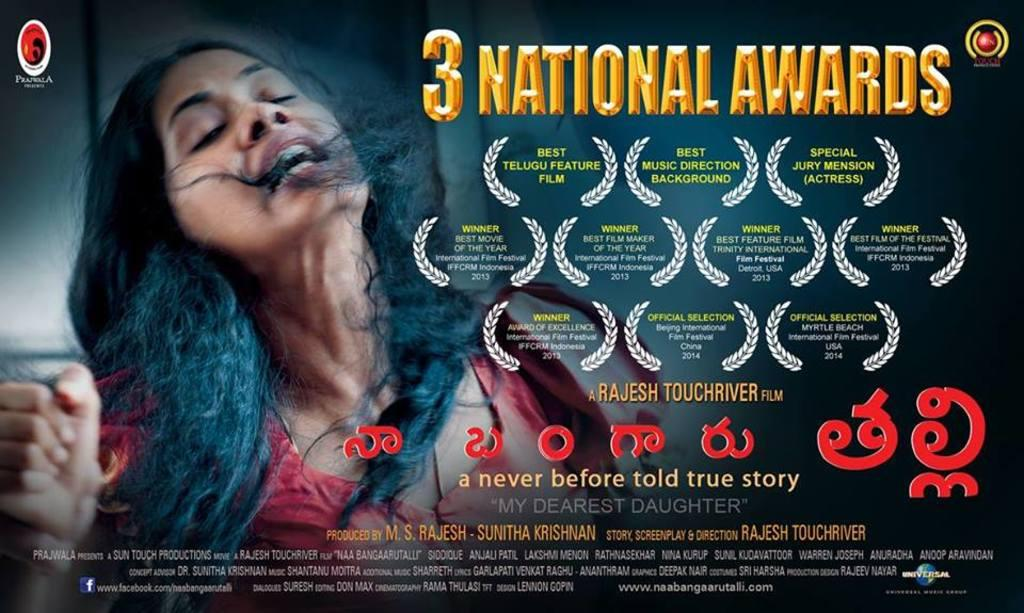<image>
Relay a brief, clear account of the picture shown. An ad showing a movie My Dearest Daughter winning three national awards. 